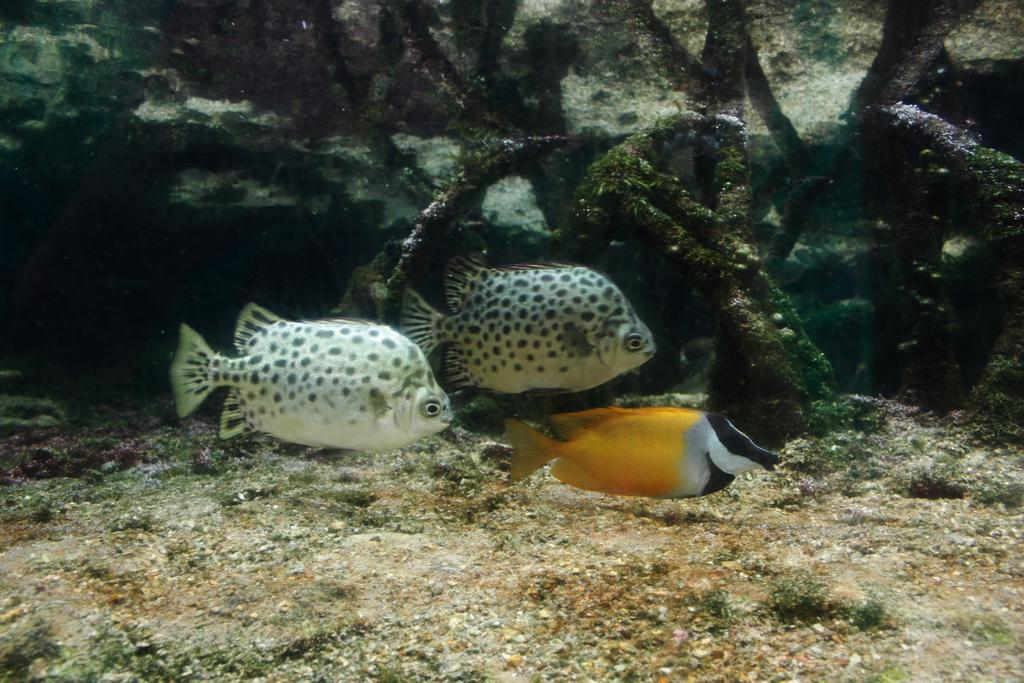What colors are the fishes in the water? There are white and black color fishes in the water. Are there any other colors of fish in the water? Yes, there is a fish in golden black color in the water. How many crackers are floating in the water with the fishes? There are no crackers present in the image; it only features fishes in the water. 